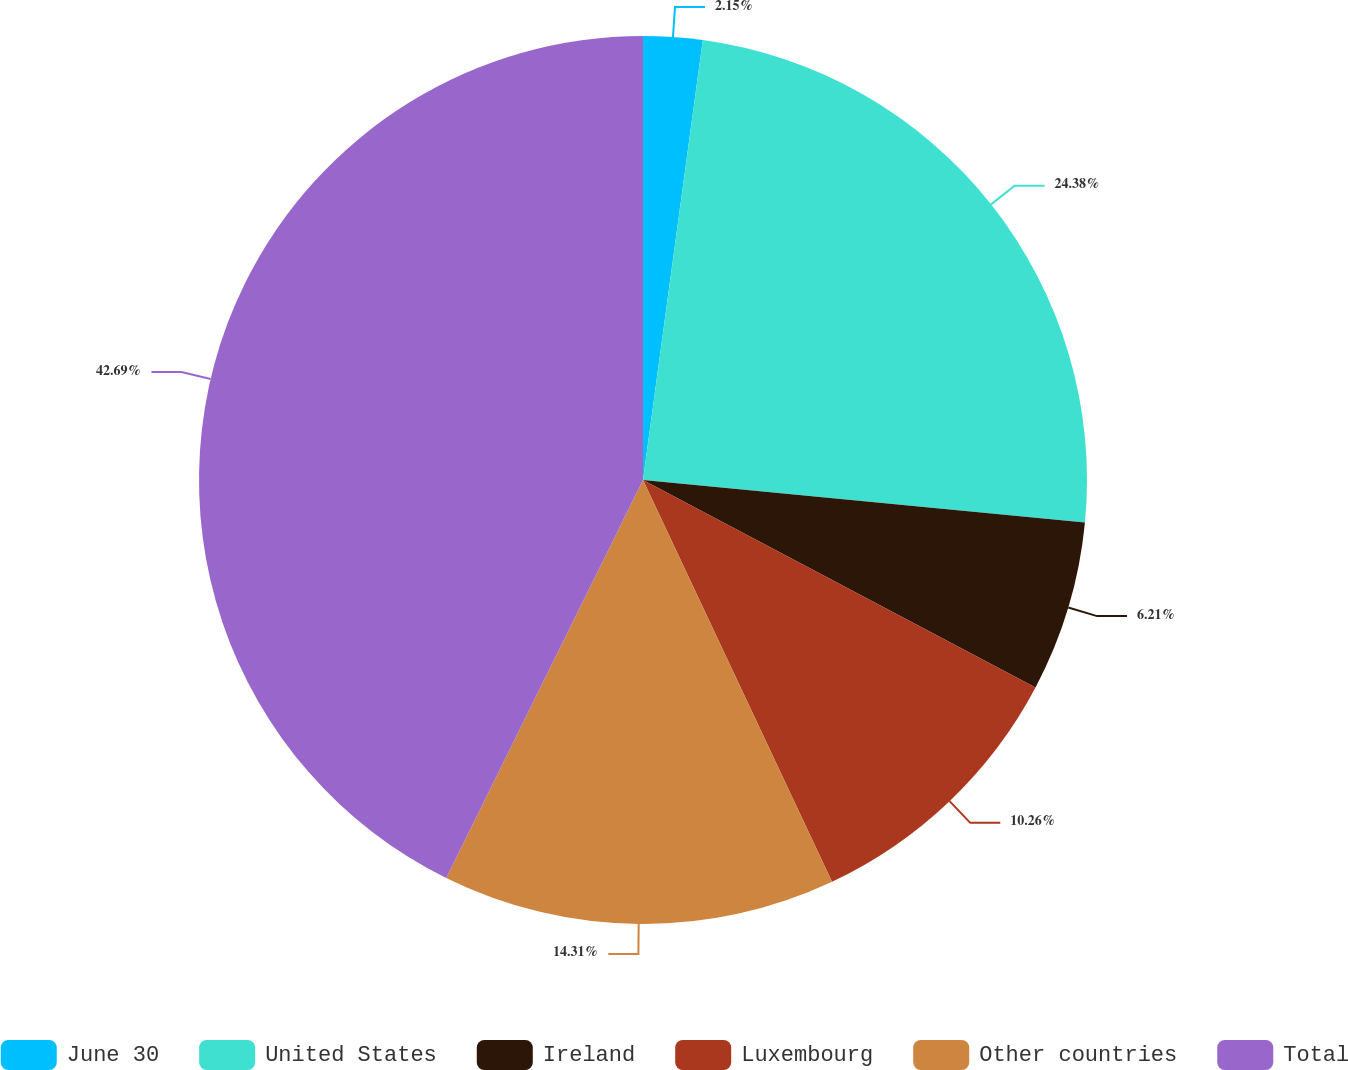Convert chart. <chart><loc_0><loc_0><loc_500><loc_500><pie_chart><fcel>June 30<fcel>United States<fcel>Ireland<fcel>Luxembourg<fcel>Other countries<fcel>Total<nl><fcel>2.15%<fcel>24.38%<fcel>6.21%<fcel>10.26%<fcel>14.31%<fcel>42.69%<nl></chart> 